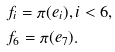<formula> <loc_0><loc_0><loc_500><loc_500>& f _ { i } = \pi ( e _ { i } ) , i < 6 , \\ & f _ { 6 } = \pi ( e _ { 7 } ) .</formula> 